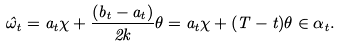Convert formula to latex. <formula><loc_0><loc_0><loc_500><loc_500>\hat { \omega } _ { t } = a _ { t } \chi + \frac { ( b _ { t } - a _ { t } ) } { 2 k } \theta = a _ { t } \chi + ( T - t ) \theta \in \alpha _ { t } .</formula> 